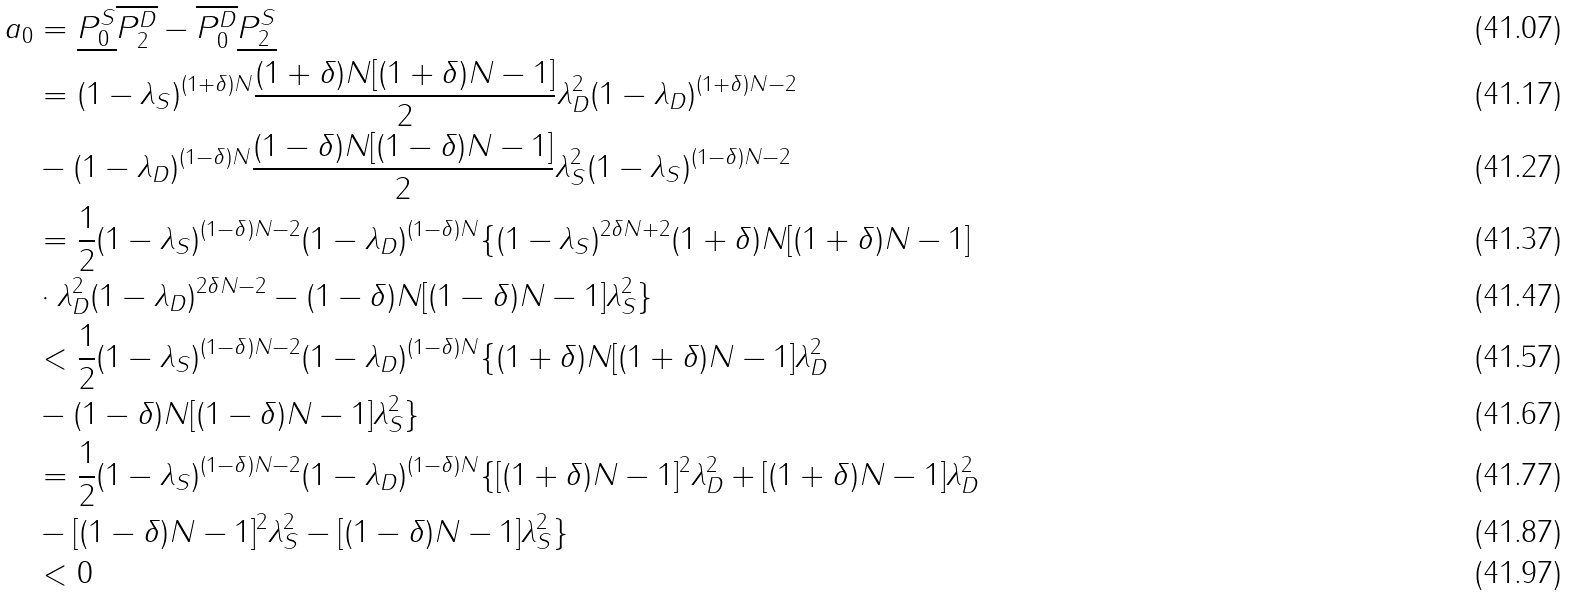Convert formula to latex. <formula><loc_0><loc_0><loc_500><loc_500>a _ { 0 } & = \underline { P _ { 0 } ^ { S } } \overline { P _ { 2 } ^ { D } } - \overline { P _ { 0 } ^ { D } } \underline { P _ { 2 } ^ { S } } \\ & = ( 1 - \lambda _ { S } ) ^ { ( 1 + \delta ) N } \frac { ( 1 + \delta ) N [ ( 1 + \delta ) N - 1 ] } { 2 } \lambda _ { D } ^ { 2 } ( 1 - \lambda _ { D } ) ^ { ( 1 + \delta ) N - 2 } \\ & - ( 1 - \lambda _ { D } ) ^ { ( 1 - \delta ) N } \frac { ( 1 - \delta ) N [ ( 1 - \delta ) N - 1 ] } { 2 } \lambda _ { S } ^ { 2 } ( 1 - \lambda _ { S } ) ^ { ( 1 - \delta ) N - 2 } \\ & = \frac { 1 } { 2 } ( 1 - \lambda _ { S } ) ^ { ( 1 - \delta ) N - 2 } ( 1 - \lambda _ { D } ) ^ { ( 1 - \delta ) N } \{ ( 1 - \lambda _ { S } ) ^ { 2 \delta N + 2 } ( 1 + \delta ) N [ ( 1 + \delta ) N - 1 ] \\ & \cdot \lambda _ { D } ^ { 2 } ( 1 - \lambda _ { D } ) ^ { 2 \delta N - 2 } - ( 1 - \delta ) N [ ( 1 - \delta ) N - 1 ] \lambda _ { S } ^ { 2 } \} \\ & < \frac { 1 } { 2 } ( 1 - \lambda _ { S } ) ^ { ( 1 - \delta ) N - 2 } ( 1 - \lambda _ { D } ) ^ { ( 1 - \delta ) N } \{ ( 1 + \delta ) N [ ( 1 + \delta ) N - 1 ] \lambda _ { D } ^ { 2 } \\ & - ( 1 - \delta ) N [ ( 1 - \delta ) N - 1 ] \lambda _ { S } ^ { 2 } \} \\ & = \frac { 1 } { 2 } ( 1 - \lambda _ { S } ) ^ { ( 1 - \delta ) N - 2 } ( 1 - \lambda _ { D } ) ^ { ( 1 - \delta ) N } \{ [ ( 1 + \delta ) N - 1 ] ^ { 2 } \lambda _ { D } ^ { 2 } + [ ( 1 + \delta ) N - 1 ] \lambda _ { D } ^ { 2 } \\ & - [ ( 1 - \delta ) N - 1 ] ^ { 2 } \lambda _ { S } ^ { 2 } - [ ( 1 - \delta ) N - 1 ] \lambda _ { S } ^ { 2 } \} \\ & < 0</formula> 